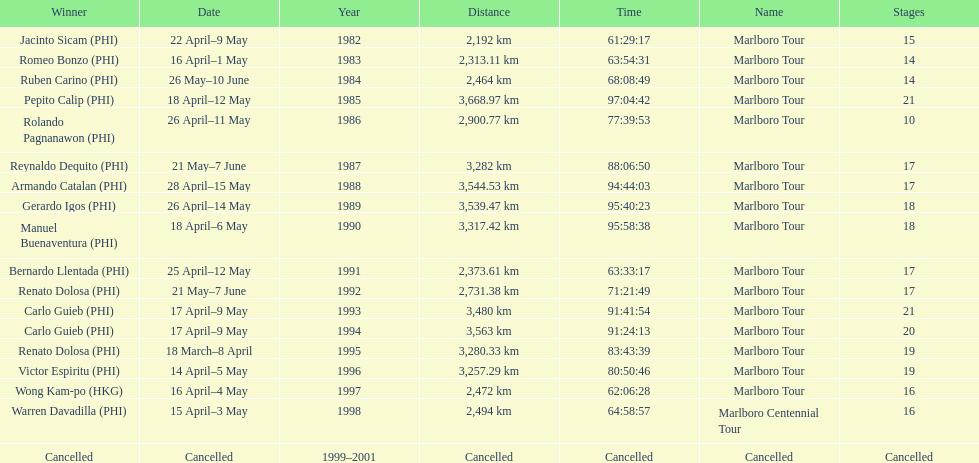Whose name is listed just ahead of wong kam-po? Victor Espiritu (PHI). 